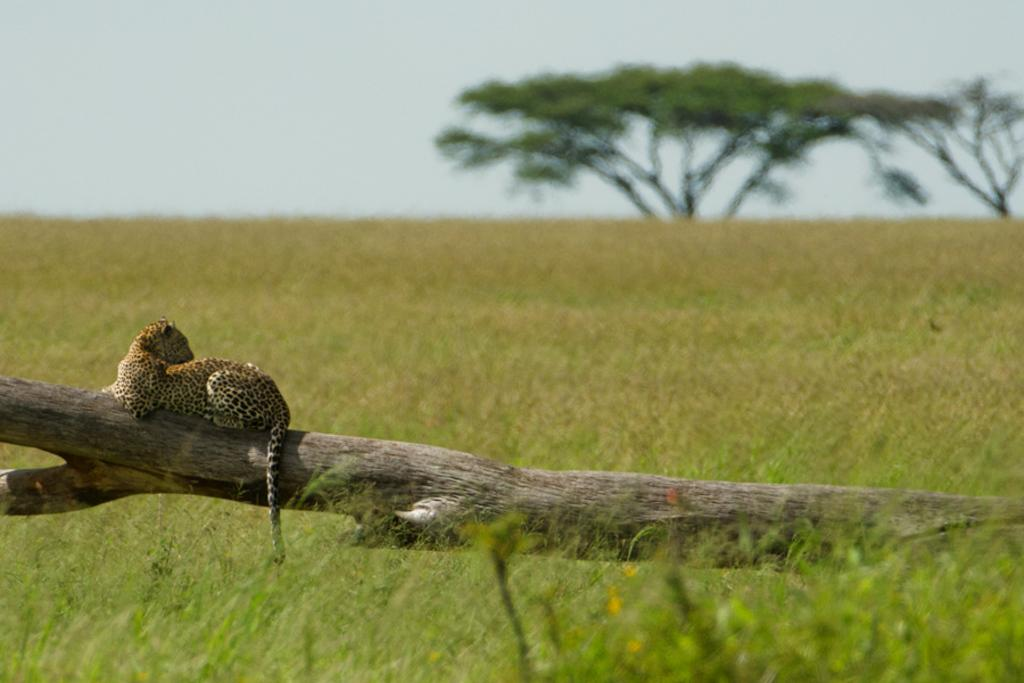What animal is the main subject of the image? There is a cheetah in the image. Where is the cheetah sitting in the image? The cheetah is sitting on a log of a tree. What type of vegetation is on the ground in the image? There is grass on the ground. What can be seen in the background of the image? There are trees and the sky visible in the background of the image. Are there any children playing with a ball in the snow in the image? No, there are no children, balls, or snow present in the image. The image features a cheetah sitting on a log of a tree, surrounded by grass and trees, with the sky visible in the background. 